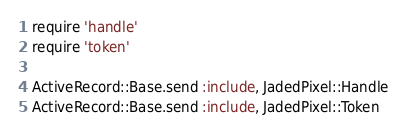<code> <loc_0><loc_0><loc_500><loc_500><_Ruby_>require 'handle'
require 'token'

ActiveRecord::Base.send :include, JadedPixel::Handle
ActiveRecord::Base.send :include, JadedPixel::Token</code> 